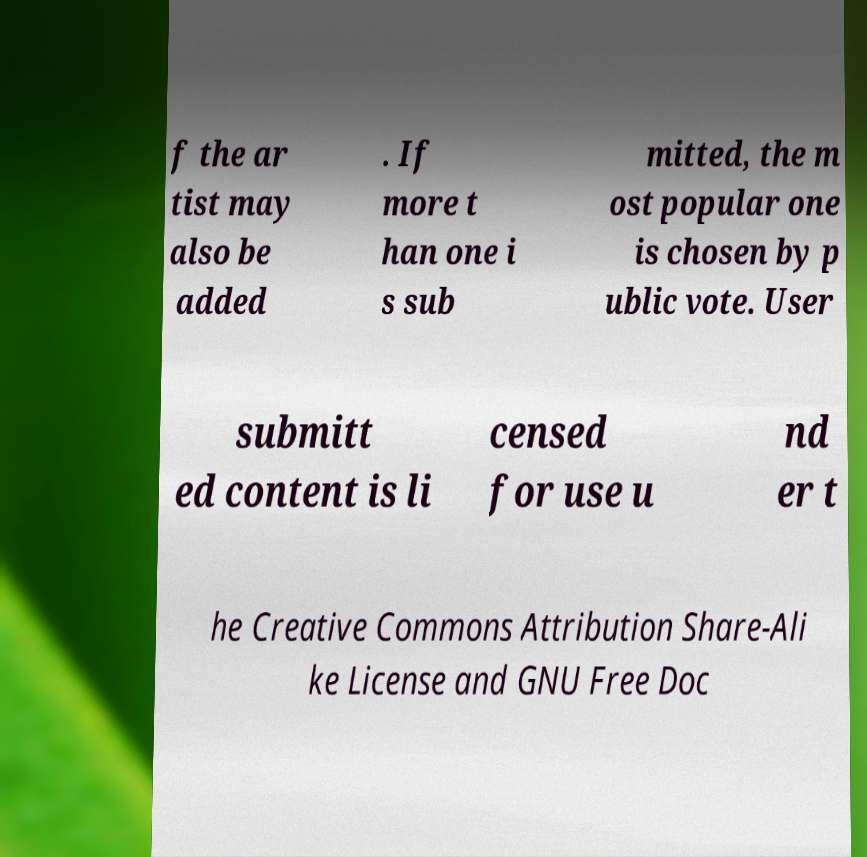Could you assist in decoding the text presented in this image and type it out clearly? f the ar tist may also be added . If more t han one i s sub mitted, the m ost popular one is chosen by p ublic vote. User submitt ed content is li censed for use u nd er t he Creative Commons Attribution Share-Ali ke License and GNU Free Doc 